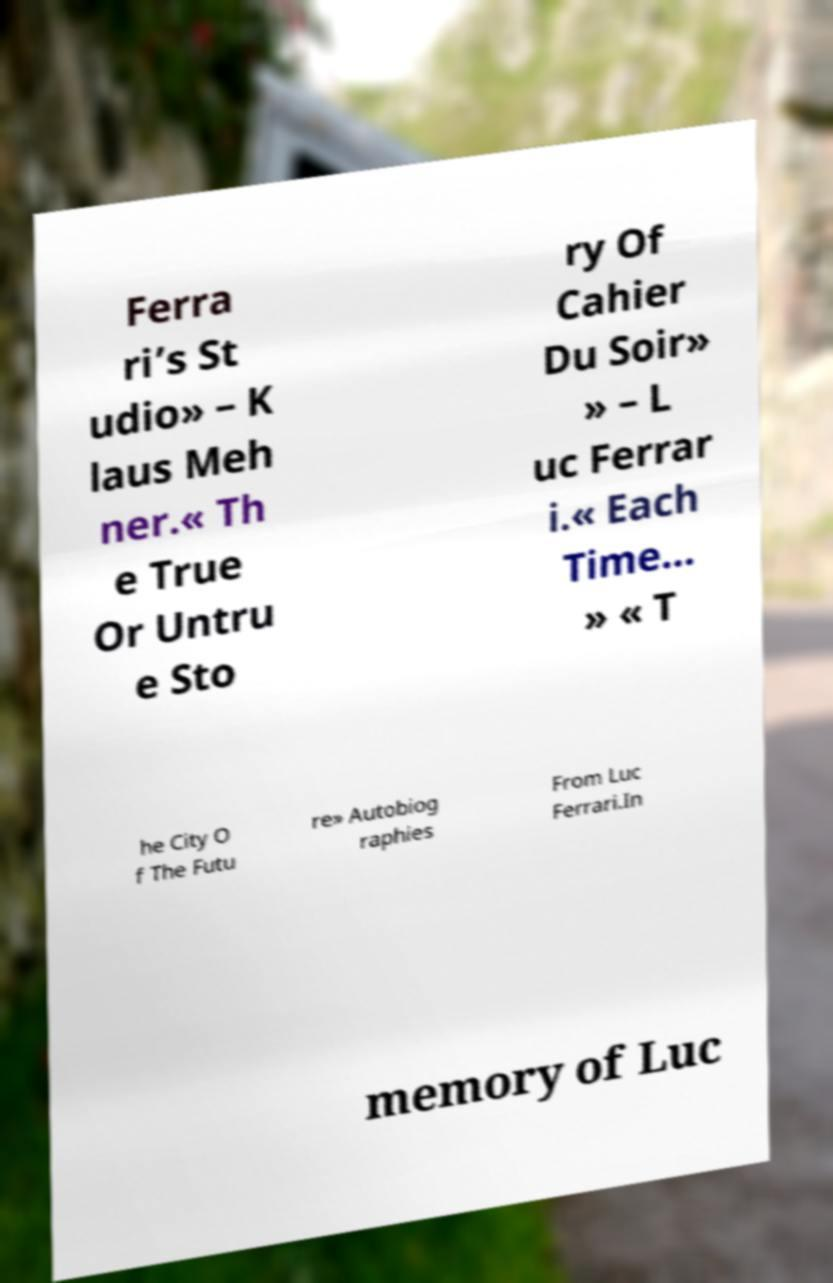Can you read and provide the text displayed in the image?This photo seems to have some interesting text. Can you extract and type it out for me? Ferra ri’s St udio» – K laus Meh ner.« Th e True Or Untru e Sto ry Of Cahier Du Soir» » – L uc Ferrar i.« Each Time… » « T he City O f The Futu re» Autobiog raphies From Luc Ferrari.In memory of Luc 